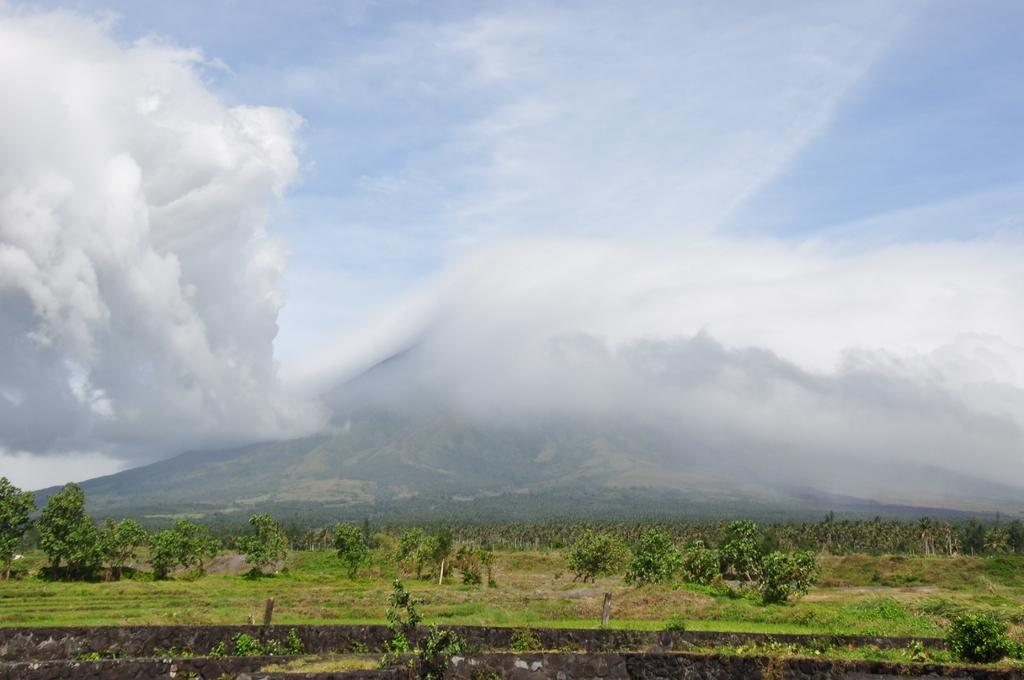What type of vegetation can be seen in the image? There are trees and plants in the image. What is the ground surface like where the trees and plants are located? The trees and plants are on land with grass. What is at the bottom of the image? There is a wall at the bottom of the image. What can be seen in the background of the image? There is a hill in the background of the image. What is visible at the top of the image? The sky is visible at the top of the image. What can be observed in the sky? There are clouds in the sky. What is the weight of the corn in the image? There is no corn present in the image, so it is not possible to determine its weight. 